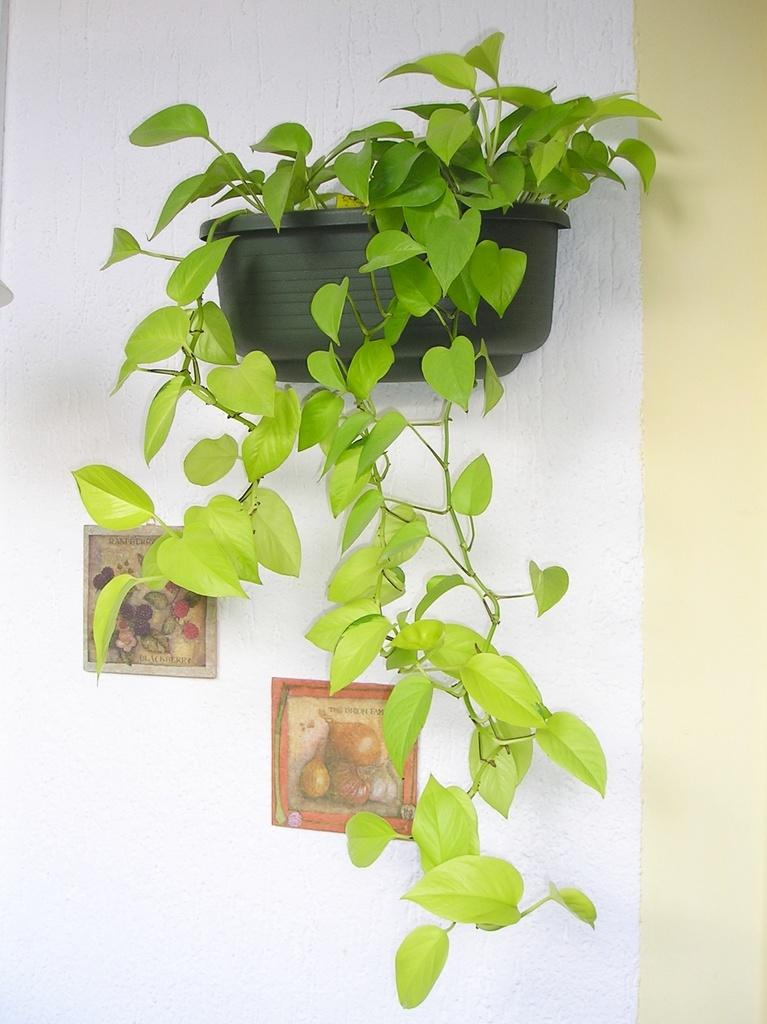What is the main subject in the center of the image? There is a wall-mounted potted plant in the center of the image. What else can be seen in the image? There are picture frames containing depictions of food items in the image. How many toothbrushes are visible in the image? There are no toothbrushes present in the image. What type of rings can be seen on the food items in the image? There are no rings present on the food items in the image, as they are depicted in picture frames. 